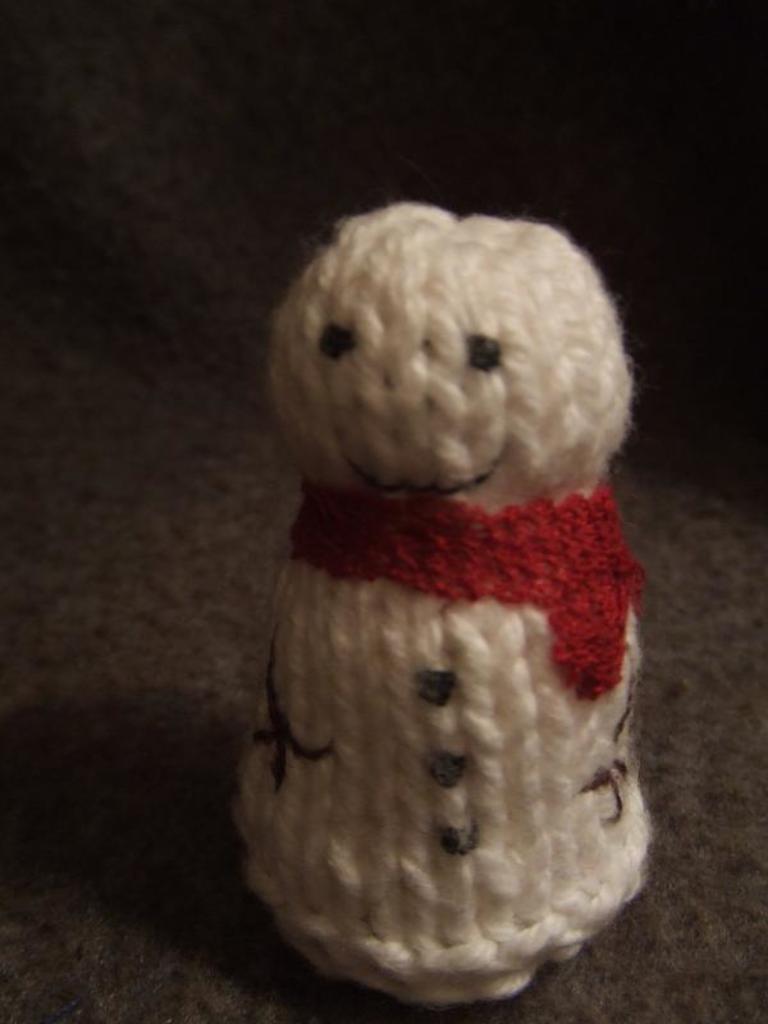Describe this image in one or two sentences. In the image we can see a woolen toy, white and red in color. 